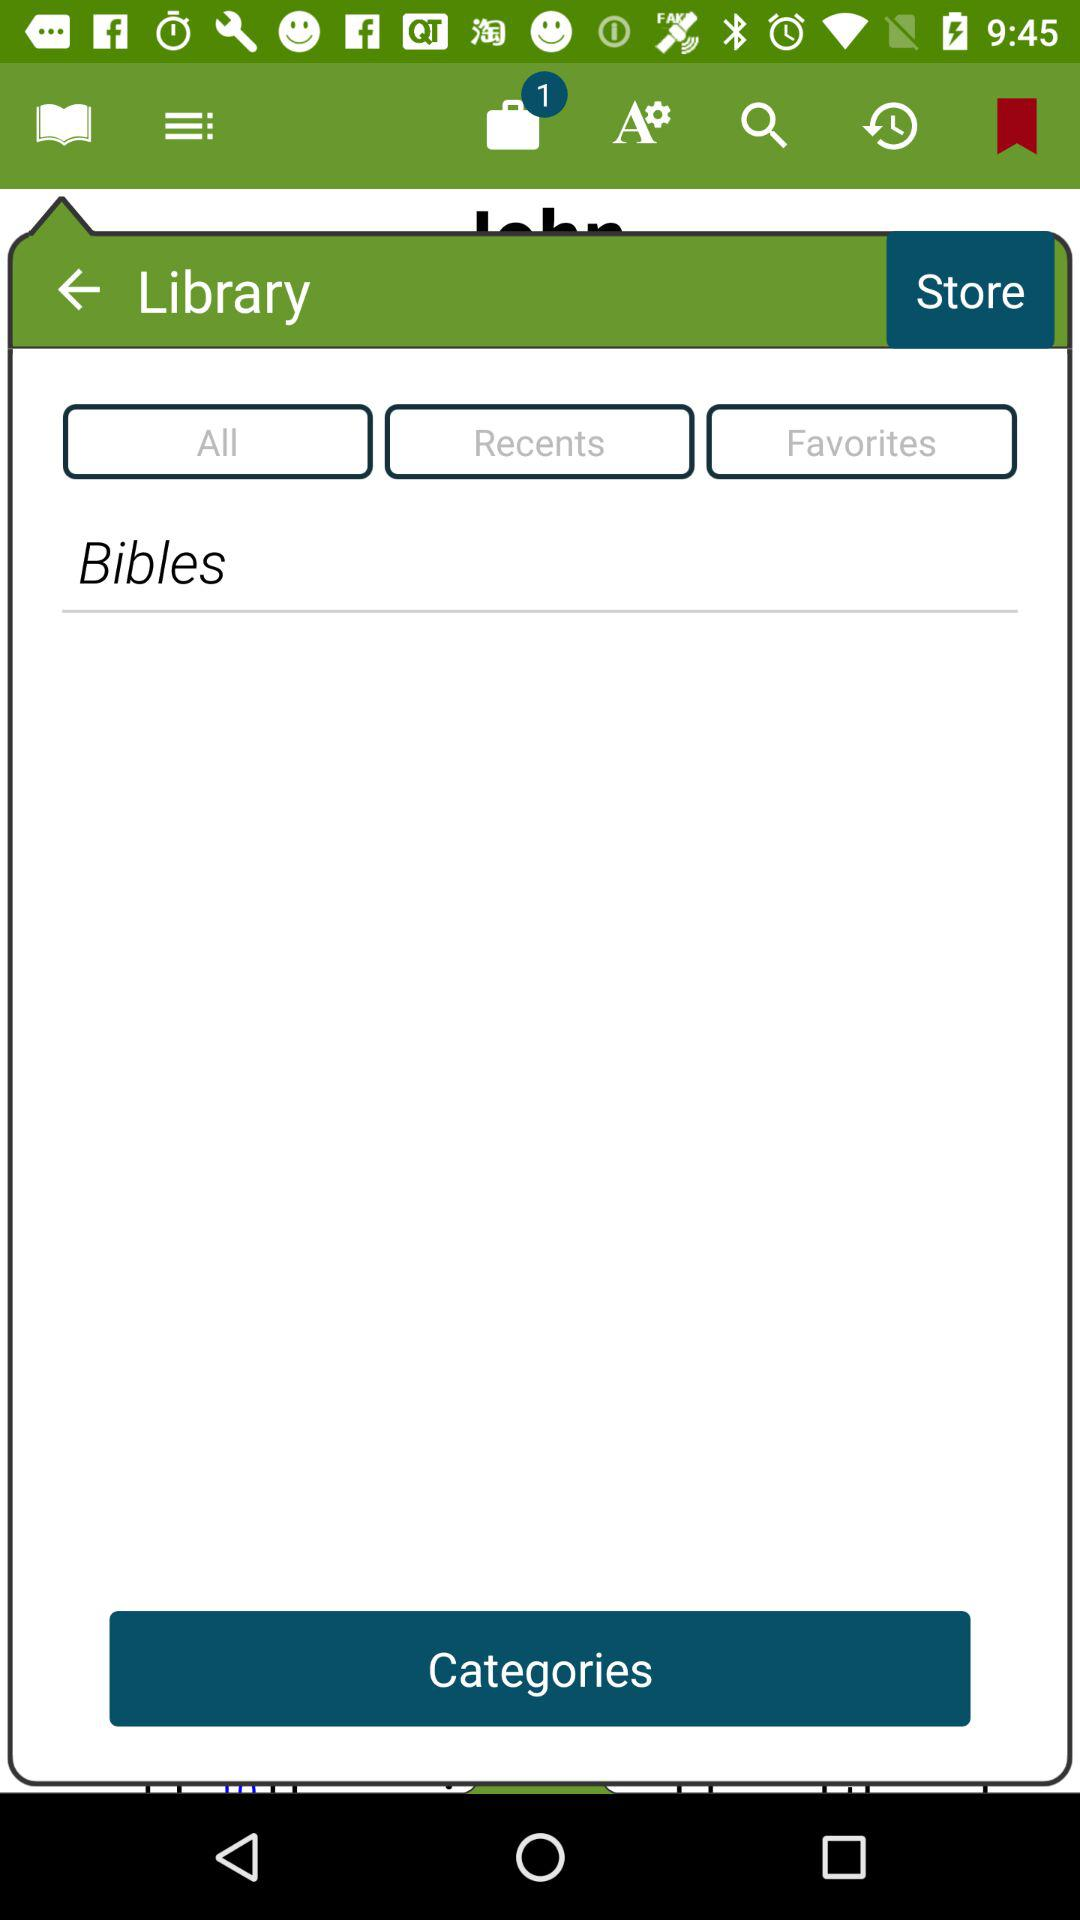What book type is selected in the library? The selected book type is "Bibles". 